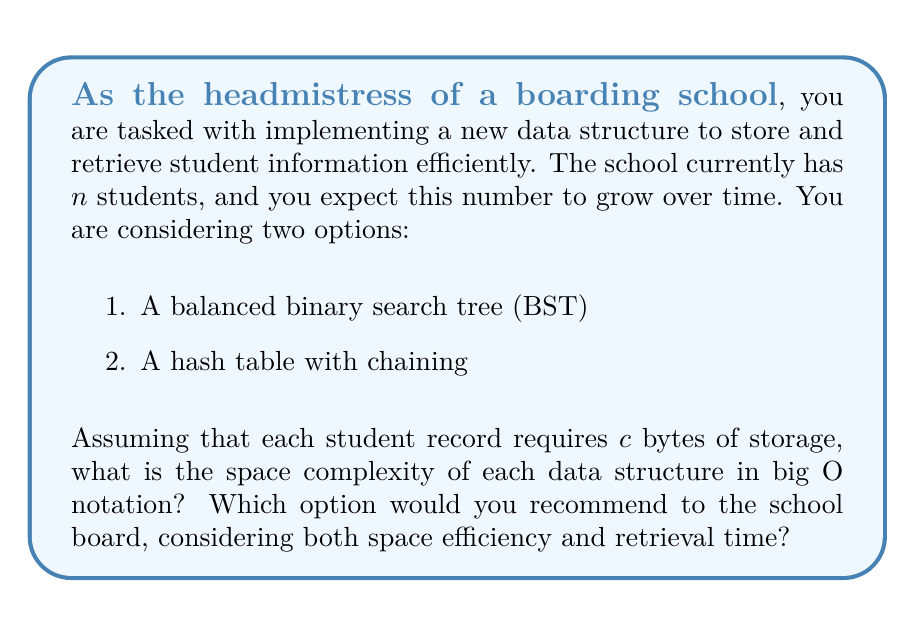Give your solution to this math problem. Let's analyze the space complexity of both data structures:

1. Balanced Binary Search Tree (BST):
   - Each node in the BST stores a student record and two pointers (left and right child).
   - The space required for each node is $O(c + p)$, where $c$ is the size of the student record and $p$ is the size of a pointer.
   - For $n$ students, we need $n$ nodes.
   - Total space complexity: $O(n(c + p)) = O(n)$, as $c$ and $p$ are constants.

2. Hash Table with Chaining:
   - The hash table consists of an array of buckets, each containing a linked list of student records.
   - Let's assume the load factor is kept below a constant $\alpha$ (e.g., 0.75) for good performance.
   - The number of buckets in the array is $m = n / \alpha = O(n)$.
   - Each bucket (pointer) requires $O(p)$ space.
   - Each student record in the linked list requires $O(c + p)$ space (data + next pointer).
   - Total space complexity: $O(m \cdot p + n(c + p)) = O(n)$

Both data structures have a space complexity of $O(n)$, which means they scale linearly with the number of students.

Recommendation:
While both options have the same space complexity, the hash table with chaining would be the better choice for the following reasons:

1. Retrieval time: Hash tables offer constant-time $O(1)$ average-case lookup, insertion, and deletion operations, assuming a good hash function and load factor. BSTs provide $O(\log n)$ time complexity for these operations.

2. Real-world performance: In practice, hash tables often outperform BSTs for large datasets due to better cache locality and simpler operations.

3. Flexibility: Hash tables can easily accommodate future growth by resizing the number of buckets, maintaining good performance.

4. Implementation simplicity: Hash tables are generally easier to implement and maintain compared to self-balancing BSTs.

Given these factors, recommending the hash table with chaining to the school board would be the most suitable choice for efficient student information storage and retrieval.
Answer: Space complexity for both data structures: $O(n)$

Recommended option: Hash table with chaining 